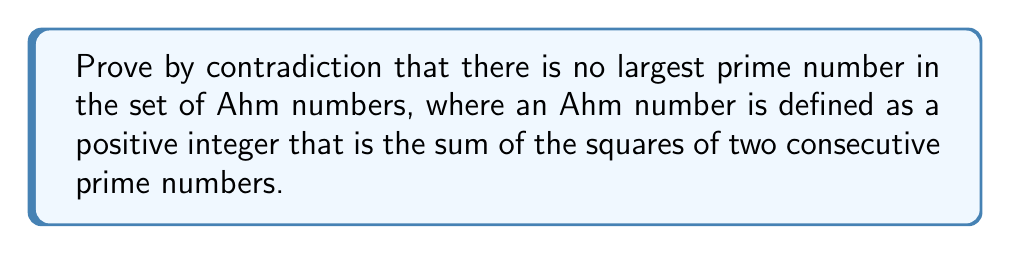Could you help me with this problem? Let's approach this proof by contradiction:

1) Assume the opposite of what we want to prove: There exists a largest prime Ahm number, call it $p$.

2) By definition, $p$ is an Ahm number, so it can be expressed as:
   $p = q^2 + r^2$, where $q$ and $r$ are consecutive prime numbers and $r = q + 2$ (since the difference between consecutive primes, except 2 and 3, is at least 2).

3) Now, let's consider the number $n = p! + 1$, where $p!$ is the factorial of $p$.

4) We can prove that $n$ is also an Ahm number:
   $n = (p!)^2 + 1^2$

5) Now, let's consider the primality of $n$:
   - $n$ is larger than $p$ (since $p! > p$ for $p > 1$)
   - $n$ is not divisible by any prime number less than or equal to $p$, because dividing $n$ by any such number always leaves a remainder of 1.

6) This means that either $n$ itself is prime, or $n$ has a prime factor larger than $p$.

7) In either case, we have found a prime Ahm number larger than $p$.

8) This contradicts our initial assumption that $p$ was the largest prime Ahm number.

Therefore, our initial assumption must be false, and there is no largest prime Ahm number.
Answer: There is no largest prime Ahm number. The proof by contradiction shows that assuming a largest prime Ahm number leads to a contradiction, thus proving that such a largest prime Ahm number cannot exist. 